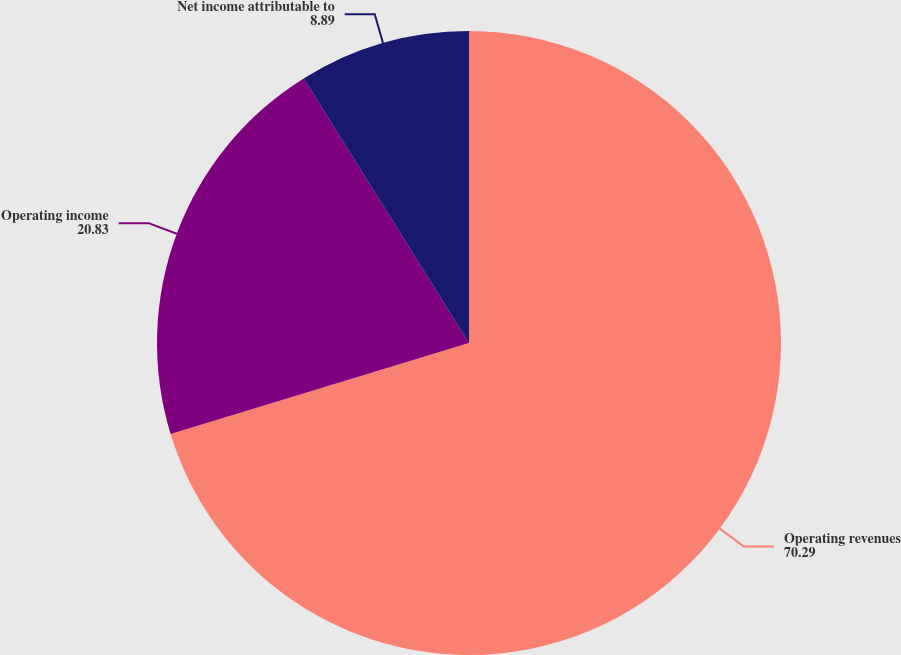Convert chart to OTSL. <chart><loc_0><loc_0><loc_500><loc_500><pie_chart><fcel>Operating revenues<fcel>Operating income<fcel>Net income attributable to<nl><fcel>70.29%<fcel>20.83%<fcel>8.89%<nl></chart> 